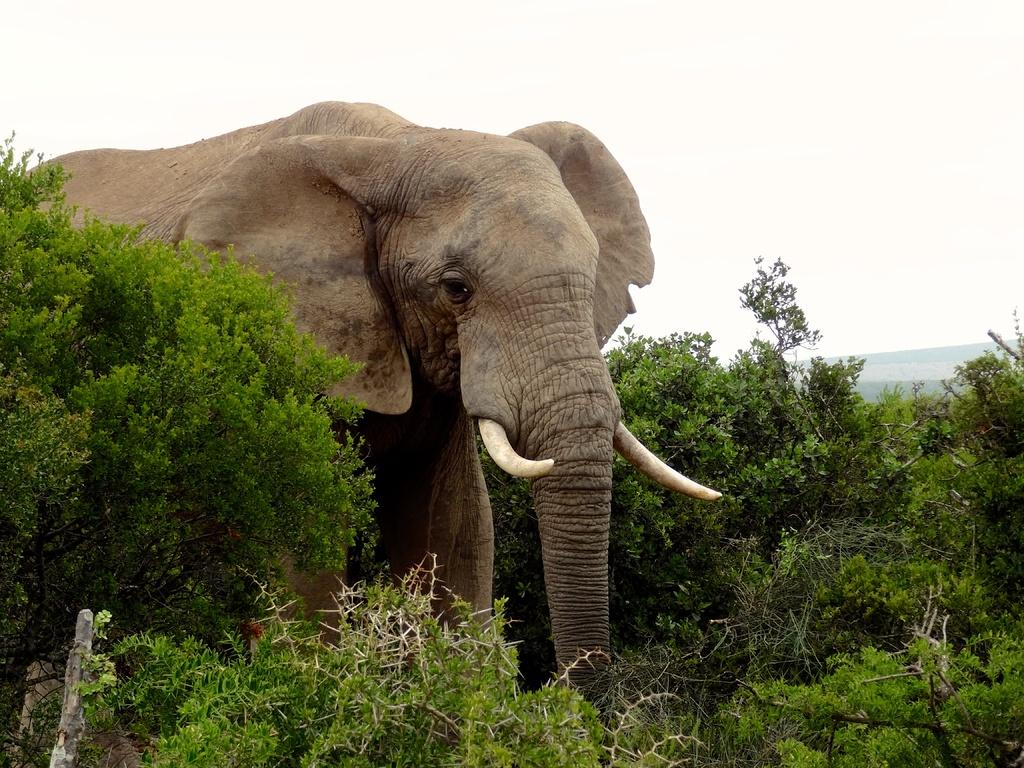What animal is present in the image? There is an elephant in the image. What type of vegetation can be seen in the image? There are trees in the image. What geographical features are visible in the image? There are hills in the image. What is visible at the top of the image? The sky is visible at the top of the image. What type of verse can be heard recited by the elephant in the image? There is no verse being recited by the elephant in the image, as it is a still image and does not contain any sounds. 